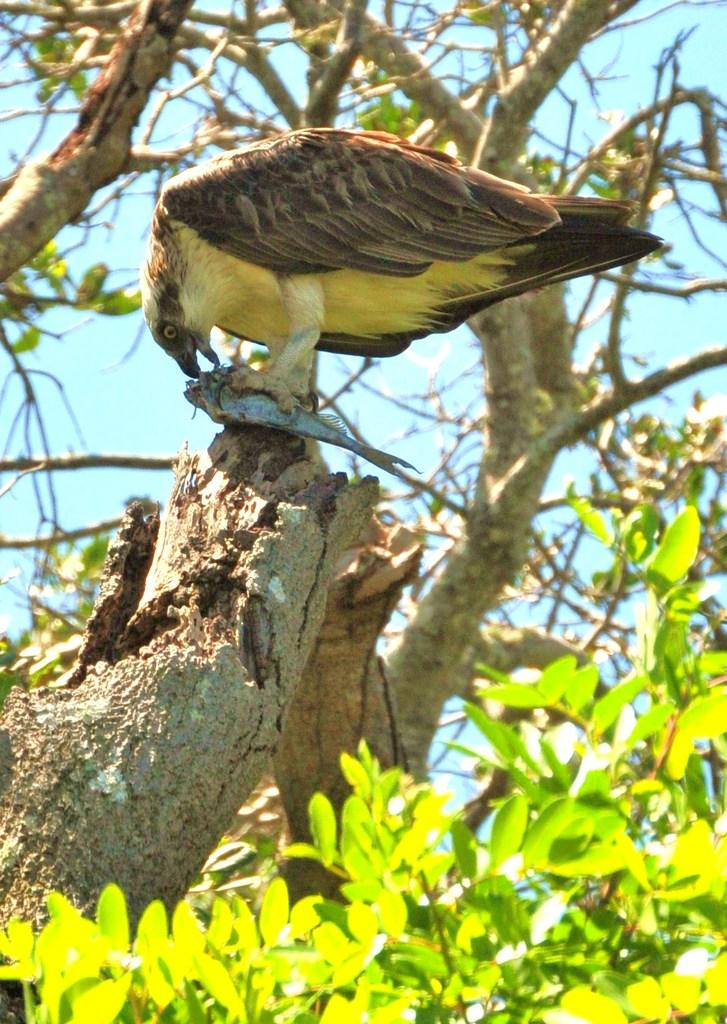What animal can be seen in the image? There is a bird in the image. Where is the bird located? The bird is on a branch. What is the bird doing in the image? The bird is eating a fish. What can be seen in the background of the image? There are trees and the sky visible in the background of the image. What invention is the bird using to catch the fish in the image? The bird does not use any invention to catch the fish in the image; it is using its natural abilities to do so. Can you see any zebras in the image? No, there are no zebras present in the image. 